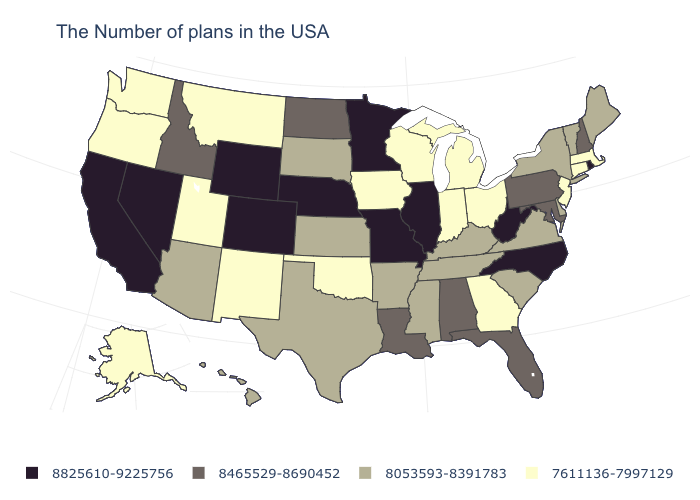Name the states that have a value in the range 8825610-9225756?
Write a very short answer. Rhode Island, North Carolina, West Virginia, Illinois, Missouri, Minnesota, Nebraska, Wyoming, Colorado, Nevada, California. What is the value of Massachusetts?
Give a very brief answer. 7611136-7997129. What is the highest value in the MidWest ?
Give a very brief answer. 8825610-9225756. What is the value of Nebraska?
Answer briefly. 8825610-9225756. Name the states that have a value in the range 7611136-7997129?
Concise answer only. Massachusetts, Connecticut, New Jersey, Ohio, Georgia, Michigan, Indiana, Wisconsin, Iowa, Oklahoma, New Mexico, Utah, Montana, Washington, Oregon, Alaska. Which states have the lowest value in the South?
Quick response, please. Georgia, Oklahoma. Which states have the highest value in the USA?
Write a very short answer. Rhode Island, North Carolina, West Virginia, Illinois, Missouri, Minnesota, Nebraska, Wyoming, Colorado, Nevada, California. Name the states that have a value in the range 7611136-7997129?
Keep it brief. Massachusetts, Connecticut, New Jersey, Ohio, Georgia, Michigan, Indiana, Wisconsin, Iowa, Oklahoma, New Mexico, Utah, Montana, Washington, Oregon, Alaska. Does West Virginia have the highest value in the USA?
Answer briefly. Yes. What is the highest value in states that border Virginia?
Keep it brief. 8825610-9225756. What is the lowest value in states that border Virginia?
Write a very short answer. 8053593-8391783. Name the states that have a value in the range 8825610-9225756?
Short answer required. Rhode Island, North Carolina, West Virginia, Illinois, Missouri, Minnesota, Nebraska, Wyoming, Colorado, Nevada, California. Does Massachusetts have the lowest value in the Northeast?
Keep it brief. Yes. Name the states that have a value in the range 8825610-9225756?
Give a very brief answer. Rhode Island, North Carolina, West Virginia, Illinois, Missouri, Minnesota, Nebraska, Wyoming, Colorado, Nevada, California. Does California have a lower value than Vermont?
Keep it brief. No. 